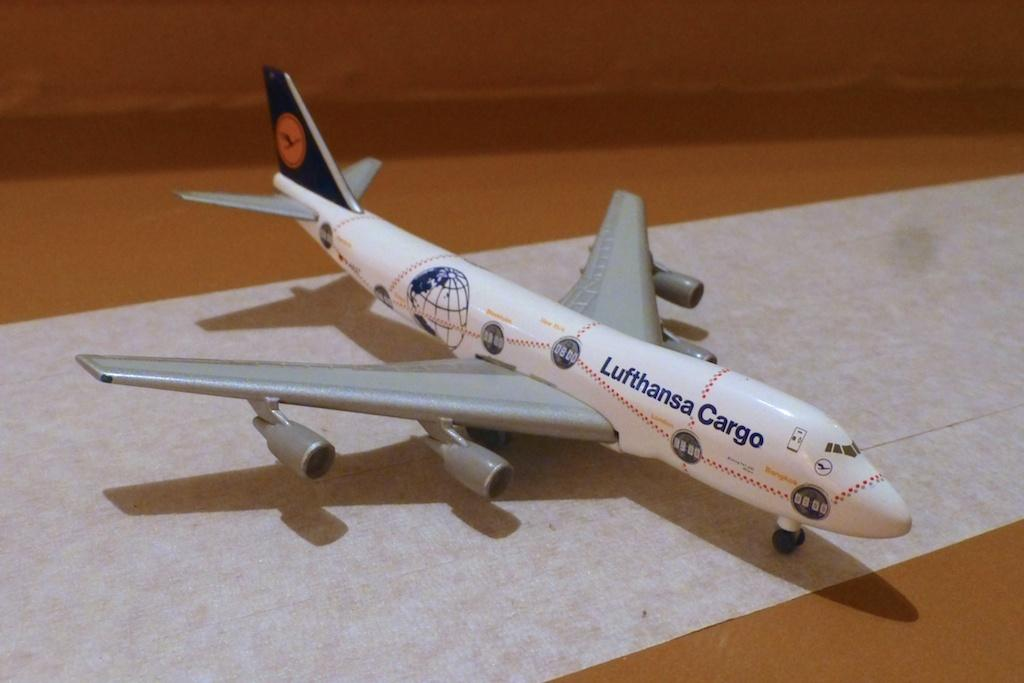Provide a one-sentence caption for the provided image. A model Lufthansa Cargo airplane sitting on a long sheet of white paper. 